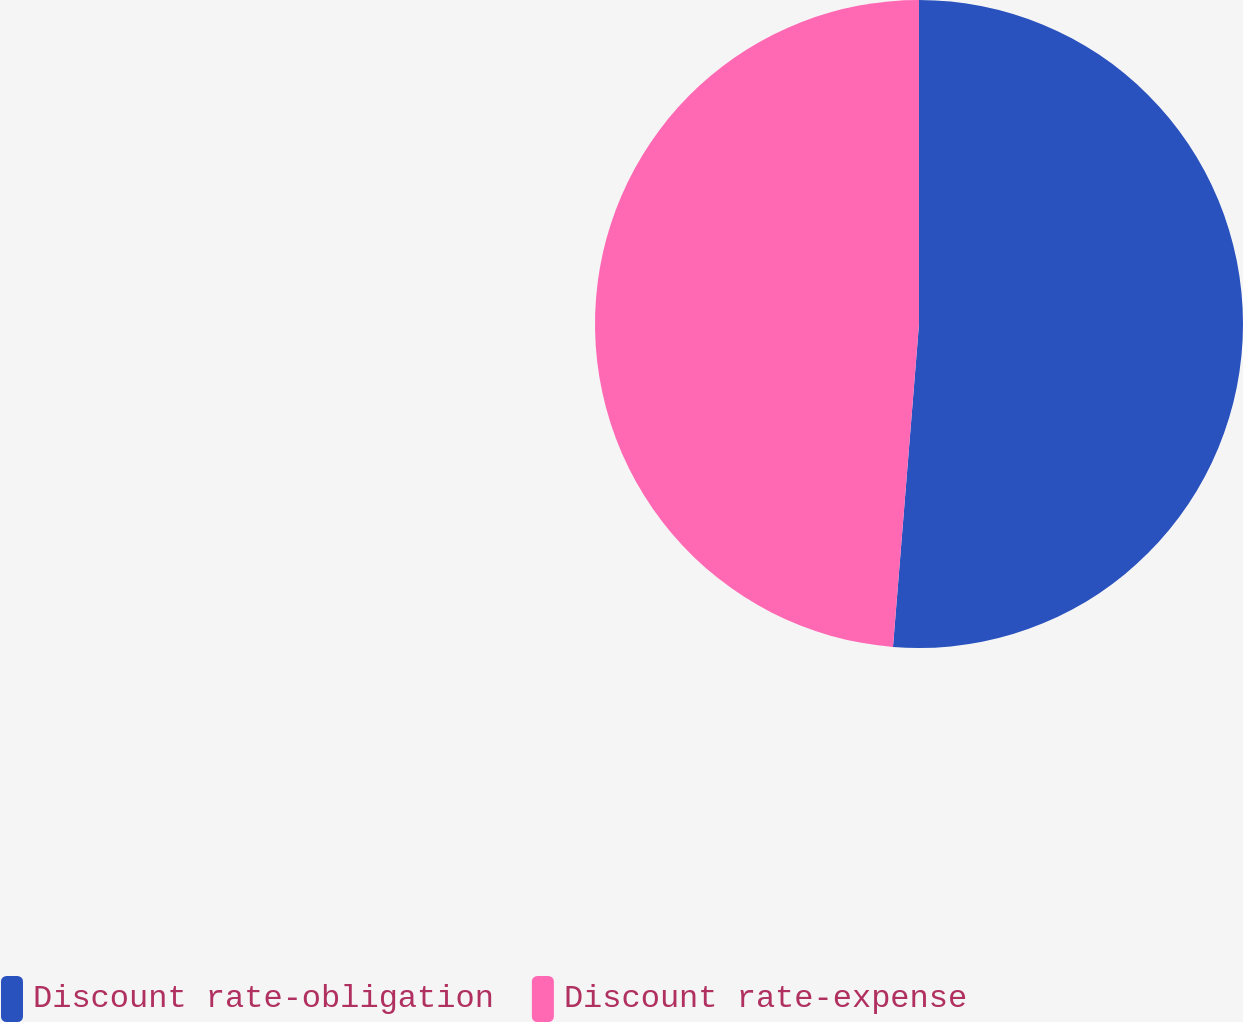Convert chart to OTSL. <chart><loc_0><loc_0><loc_500><loc_500><pie_chart><fcel>Discount rate-obligation<fcel>Discount rate-expense<nl><fcel>51.28%<fcel>48.72%<nl></chart> 